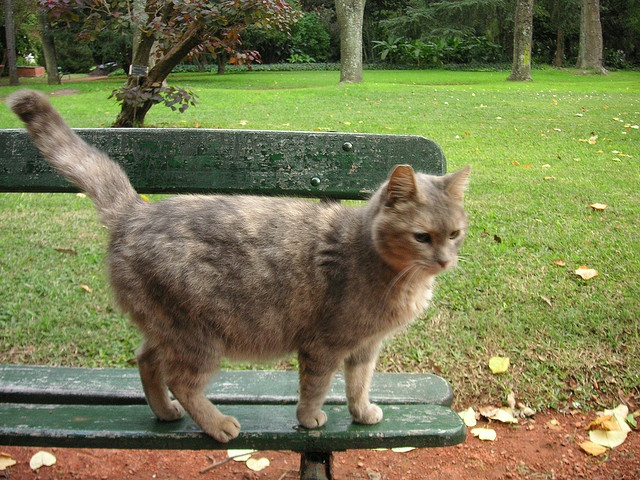Describe the objects in this image and their specific colors. I can see cat in black, gray, maroon, and darkgray tones, bench in black, gray, darkgray, and darkgreen tones, and bench in black, darkgreen, gray, and olive tones in this image. 